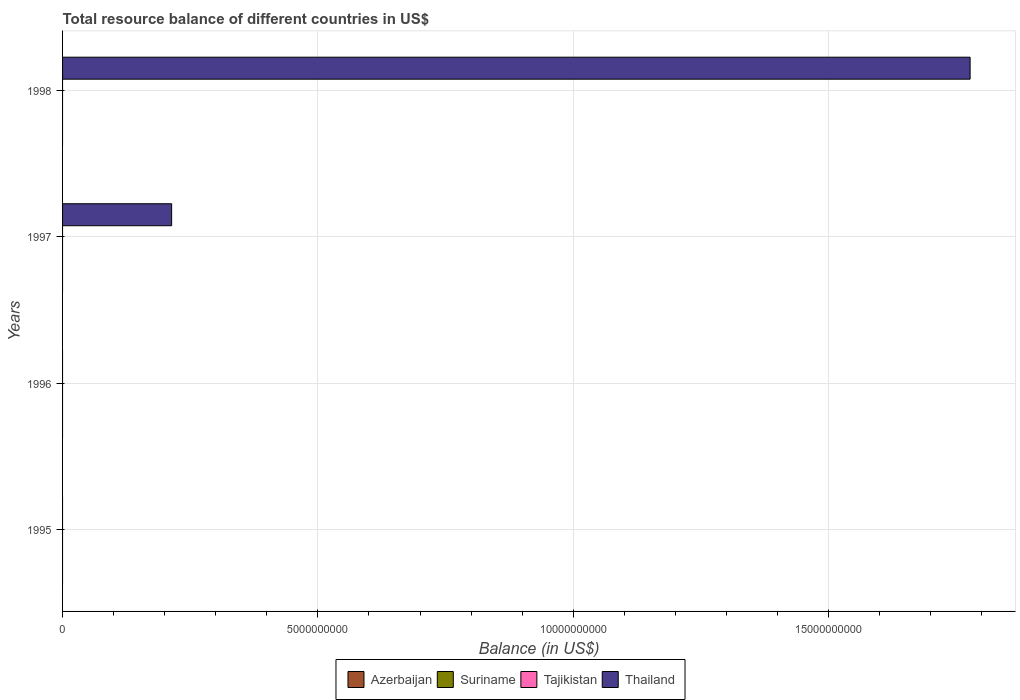How many different coloured bars are there?
Offer a very short reply. 1. Are the number of bars per tick equal to the number of legend labels?
Your answer should be very brief. No. Are the number of bars on each tick of the Y-axis equal?
Provide a succinct answer. No. Across all years, what is the maximum total resource balance in Thailand?
Keep it short and to the point. 1.78e+1. In which year was the total resource balance in Thailand maximum?
Your answer should be very brief. 1998. What is the total total resource balance in Azerbaijan in the graph?
Provide a succinct answer. 0. What is the difference between the total resource balance in Tajikistan in 1996 and the total resource balance in Azerbaijan in 1998?
Provide a short and direct response. 0. What is the average total resource balance in Thailand per year?
Provide a short and direct response. 4.98e+09. In how many years, is the total resource balance in Tajikistan greater than 10000000000 US$?
Your response must be concise. 0. What is the difference between the highest and the lowest total resource balance in Thailand?
Give a very brief answer. 1.78e+1. Is it the case that in every year, the sum of the total resource balance in Suriname and total resource balance in Azerbaijan is greater than the total resource balance in Thailand?
Keep it short and to the point. No. Are the values on the major ticks of X-axis written in scientific E-notation?
Offer a very short reply. No. Where does the legend appear in the graph?
Provide a short and direct response. Bottom center. What is the title of the graph?
Offer a very short reply. Total resource balance of different countries in US$. What is the label or title of the X-axis?
Give a very brief answer. Balance (in US$). What is the label or title of the Y-axis?
Make the answer very short. Years. What is the Balance (in US$) of Suriname in 1995?
Keep it short and to the point. 0. What is the Balance (in US$) of Tajikistan in 1995?
Your answer should be compact. 0. What is the Balance (in US$) in Azerbaijan in 1996?
Keep it short and to the point. 0. What is the Balance (in US$) in Suriname in 1997?
Your response must be concise. 0. What is the Balance (in US$) in Tajikistan in 1997?
Offer a very short reply. 0. What is the Balance (in US$) in Thailand in 1997?
Keep it short and to the point. 2.14e+09. What is the Balance (in US$) of Thailand in 1998?
Your answer should be very brief. 1.78e+1. Across all years, what is the maximum Balance (in US$) in Thailand?
Keep it short and to the point. 1.78e+1. Across all years, what is the minimum Balance (in US$) in Thailand?
Keep it short and to the point. 0. What is the total Balance (in US$) of Azerbaijan in the graph?
Your answer should be very brief. 0. What is the total Balance (in US$) in Tajikistan in the graph?
Keep it short and to the point. 0. What is the total Balance (in US$) in Thailand in the graph?
Your answer should be very brief. 1.99e+1. What is the difference between the Balance (in US$) of Thailand in 1997 and that in 1998?
Ensure brevity in your answer.  -1.56e+1. What is the average Balance (in US$) in Tajikistan per year?
Keep it short and to the point. 0. What is the average Balance (in US$) of Thailand per year?
Offer a terse response. 4.98e+09. What is the ratio of the Balance (in US$) of Thailand in 1997 to that in 1998?
Give a very brief answer. 0.12. What is the difference between the highest and the lowest Balance (in US$) of Thailand?
Provide a short and direct response. 1.78e+1. 